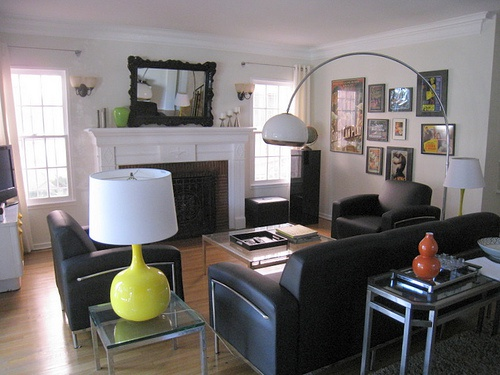Describe the objects in this image and their specific colors. I can see couch in gray, black, and darkblue tones, chair in gray, black, and darkgray tones, chair in gray and black tones, vase in gray, maroon, and brown tones, and tv in gray, darkgray, and black tones in this image. 